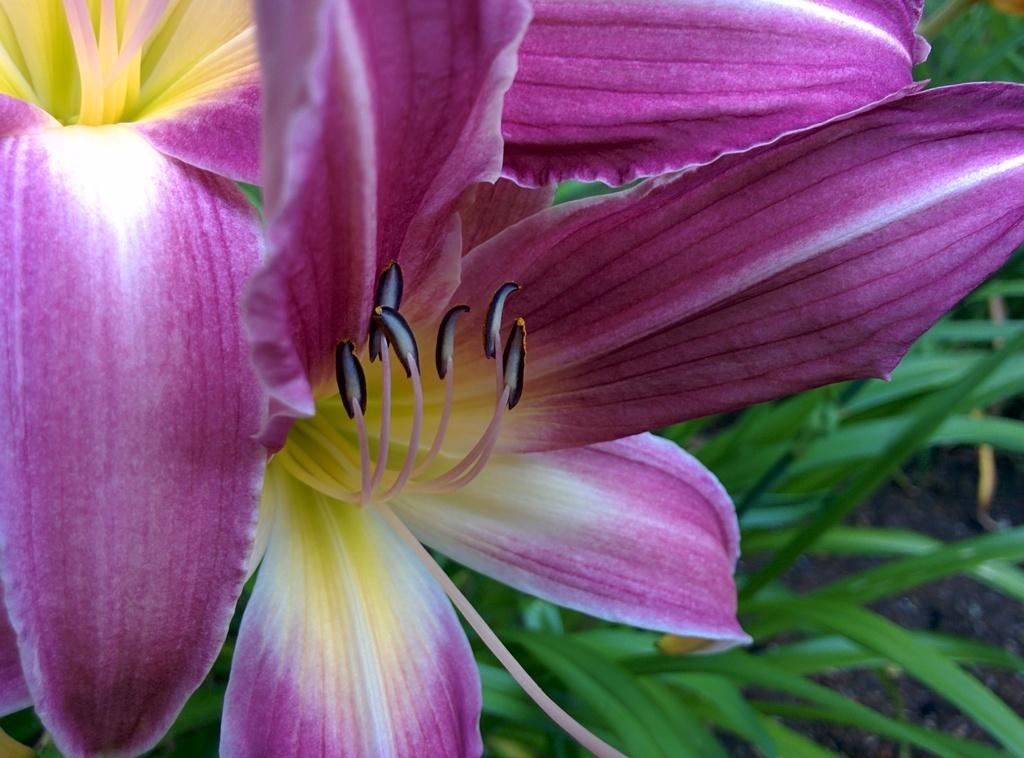What type of plants can be seen in the image? There are flowers and leaves in the image. Can you describe the appearance of the flowers? Unfortunately, the specific appearance of the flowers cannot be determined from the provided facts. What is the relationship between the flowers and leaves in the image? The flowers and leaves are likely part of the same plant, as they are both present in the image. How many babies are visible in the image? There are no babies present in the image; it features flowers and leaves. Can you describe how the flowers turn in the image? The flowers do not turn in the image; they are stationary. 